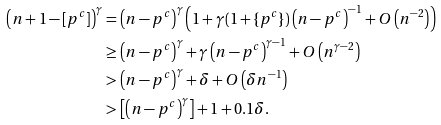Convert formula to latex. <formula><loc_0><loc_0><loc_500><loc_500>\left ( n + 1 - [ p ^ { c } ] \right ) ^ { \gamma } & = \left ( n - p ^ { c } \right ) ^ { \gamma } \left ( 1 + \gamma ( 1 + \{ p ^ { c } \} ) \left ( n - p ^ { c } \right ) ^ { - 1 } + O \left ( n ^ { - 2 } \right ) \right ) \\ & \geq \left ( n - p ^ { c } \right ) ^ { \gamma } + \gamma \left ( n - p ^ { c } \right ) ^ { \gamma - 1 } + O \left ( n ^ { \gamma - 2 } \right ) \\ & > \left ( n - p ^ { c } \right ) ^ { \gamma } + \delta + O \left ( \delta n ^ { - 1 } \right ) \\ & > \left [ \left ( n - p ^ { c } \right ) ^ { \gamma } \right ] + 1 + 0 . 1 \delta .</formula> 